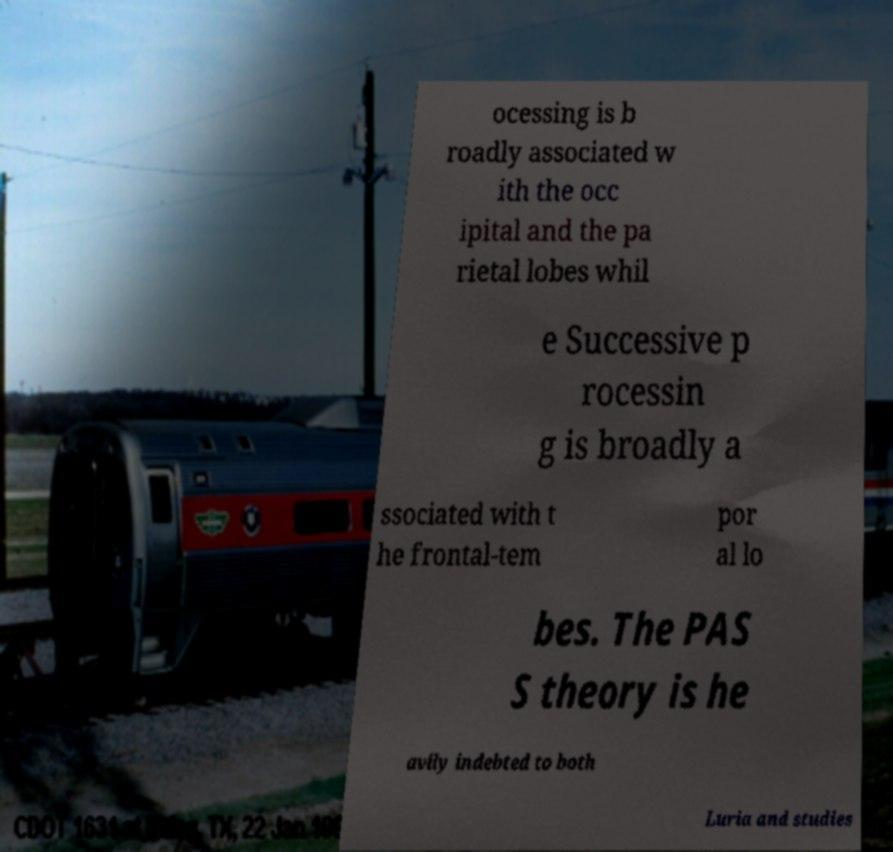For documentation purposes, I need the text within this image transcribed. Could you provide that? ocessing is b roadly associated w ith the occ ipital and the pa rietal lobes whil e Successive p rocessin g is broadly a ssociated with t he frontal-tem por al lo bes. The PAS S theory is he avily indebted to both Luria and studies 